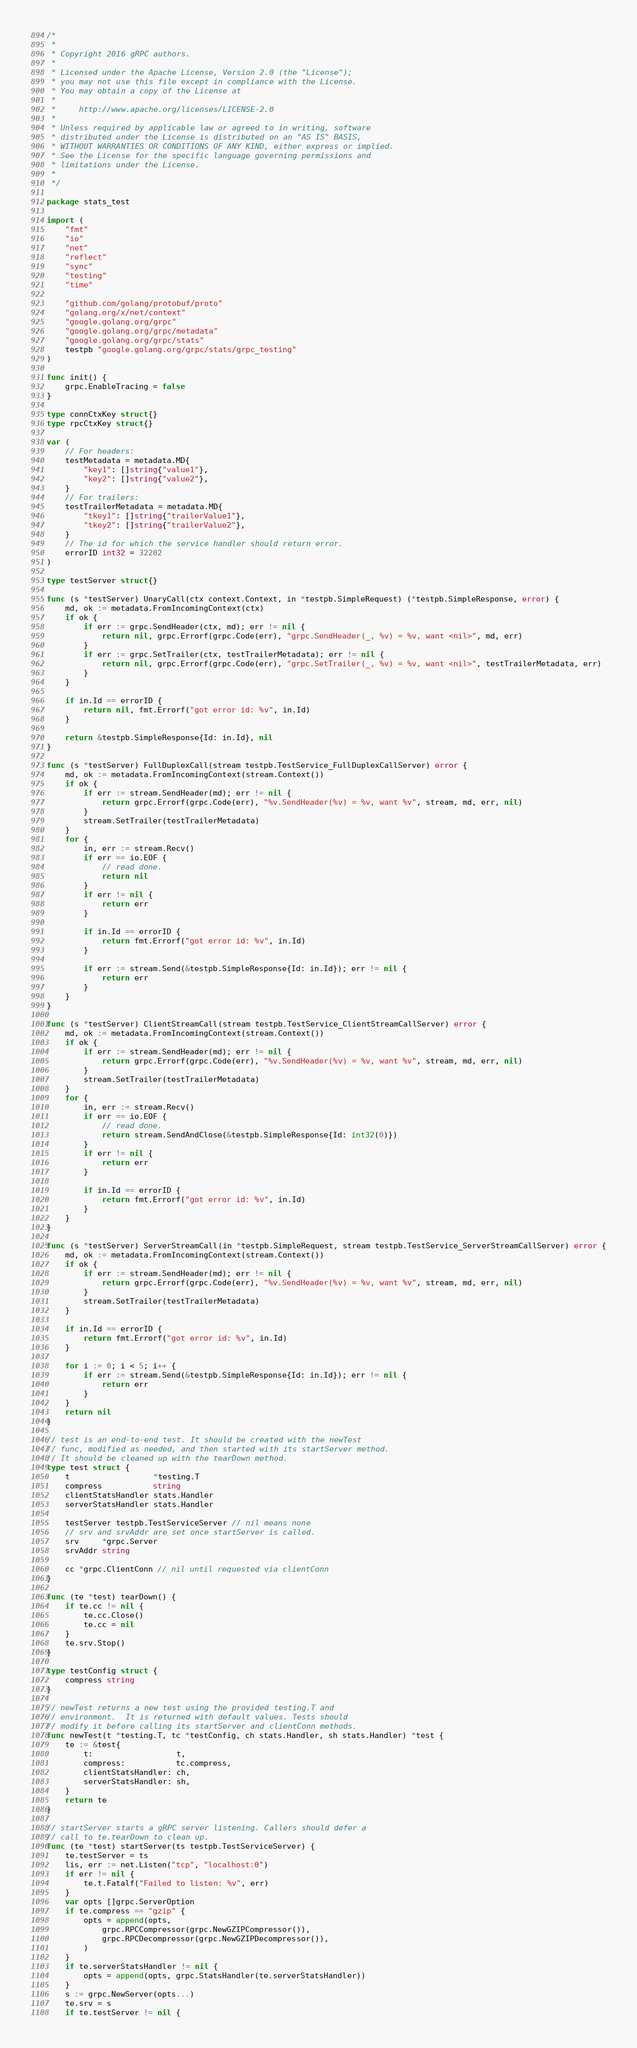Convert code to text. <code><loc_0><loc_0><loc_500><loc_500><_Go_>/*
 *
 * Copyright 2016 gRPC authors.
 *
 * Licensed under the Apache License, Version 2.0 (the "License");
 * you may not use this file except in compliance with the License.
 * You may obtain a copy of the License at
 *
 *     http://www.apache.org/licenses/LICENSE-2.0
 *
 * Unless required by applicable law or agreed to in writing, software
 * distributed under the License is distributed on an "AS IS" BASIS,
 * WITHOUT WARRANTIES OR CONDITIONS OF ANY KIND, either express or implied.
 * See the License for the specific language governing permissions and
 * limitations under the License.
 *
 */

package stats_test

import (
	"fmt"
	"io"
	"net"
	"reflect"
	"sync"
	"testing"
	"time"

	"github.com/golang/protobuf/proto"
	"golang.org/x/net/context"
	"google.golang.org/grpc"
	"google.golang.org/grpc/metadata"
	"google.golang.org/grpc/stats"
	testpb "google.golang.org/grpc/stats/grpc_testing"
)

func init() {
	grpc.EnableTracing = false
}

type connCtxKey struct{}
type rpcCtxKey struct{}

var (
	// For headers:
	testMetadata = metadata.MD{
		"key1": []string{"value1"},
		"key2": []string{"value2"},
	}
	// For trailers:
	testTrailerMetadata = metadata.MD{
		"tkey1": []string{"trailerValue1"},
		"tkey2": []string{"trailerValue2"},
	}
	// The id for which the service handler should return error.
	errorID int32 = 32202
)

type testServer struct{}

func (s *testServer) UnaryCall(ctx context.Context, in *testpb.SimpleRequest) (*testpb.SimpleResponse, error) {
	md, ok := metadata.FromIncomingContext(ctx)
	if ok {
		if err := grpc.SendHeader(ctx, md); err != nil {
			return nil, grpc.Errorf(grpc.Code(err), "grpc.SendHeader(_, %v) = %v, want <nil>", md, err)
		}
		if err := grpc.SetTrailer(ctx, testTrailerMetadata); err != nil {
			return nil, grpc.Errorf(grpc.Code(err), "grpc.SetTrailer(_, %v) = %v, want <nil>", testTrailerMetadata, err)
		}
	}

	if in.Id == errorID {
		return nil, fmt.Errorf("got error id: %v", in.Id)
	}

	return &testpb.SimpleResponse{Id: in.Id}, nil
}

func (s *testServer) FullDuplexCall(stream testpb.TestService_FullDuplexCallServer) error {
	md, ok := metadata.FromIncomingContext(stream.Context())
	if ok {
		if err := stream.SendHeader(md); err != nil {
			return grpc.Errorf(grpc.Code(err), "%v.SendHeader(%v) = %v, want %v", stream, md, err, nil)
		}
		stream.SetTrailer(testTrailerMetadata)
	}
	for {
		in, err := stream.Recv()
		if err == io.EOF {
			// read done.
			return nil
		}
		if err != nil {
			return err
		}

		if in.Id == errorID {
			return fmt.Errorf("got error id: %v", in.Id)
		}

		if err := stream.Send(&testpb.SimpleResponse{Id: in.Id}); err != nil {
			return err
		}
	}
}

func (s *testServer) ClientStreamCall(stream testpb.TestService_ClientStreamCallServer) error {
	md, ok := metadata.FromIncomingContext(stream.Context())
	if ok {
		if err := stream.SendHeader(md); err != nil {
			return grpc.Errorf(grpc.Code(err), "%v.SendHeader(%v) = %v, want %v", stream, md, err, nil)
		}
		stream.SetTrailer(testTrailerMetadata)
	}
	for {
		in, err := stream.Recv()
		if err == io.EOF {
			// read done.
			return stream.SendAndClose(&testpb.SimpleResponse{Id: int32(0)})
		}
		if err != nil {
			return err
		}

		if in.Id == errorID {
			return fmt.Errorf("got error id: %v", in.Id)
		}
	}
}

func (s *testServer) ServerStreamCall(in *testpb.SimpleRequest, stream testpb.TestService_ServerStreamCallServer) error {
	md, ok := metadata.FromIncomingContext(stream.Context())
	if ok {
		if err := stream.SendHeader(md); err != nil {
			return grpc.Errorf(grpc.Code(err), "%v.SendHeader(%v) = %v, want %v", stream, md, err, nil)
		}
		stream.SetTrailer(testTrailerMetadata)
	}

	if in.Id == errorID {
		return fmt.Errorf("got error id: %v", in.Id)
	}

	for i := 0; i < 5; i++ {
		if err := stream.Send(&testpb.SimpleResponse{Id: in.Id}); err != nil {
			return err
		}
	}
	return nil
}

// test is an end-to-end test. It should be created with the newTest
// func, modified as needed, and then started with its startServer method.
// It should be cleaned up with the tearDown method.
type test struct {
	t                  *testing.T
	compress           string
	clientStatsHandler stats.Handler
	serverStatsHandler stats.Handler

	testServer testpb.TestServiceServer // nil means none
	// srv and srvAddr are set once startServer is called.
	srv     *grpc.Server
	srvAddr string

	cc *grpc.ClientConn // nil until requested via clientConn
}

func (te *test) tearDown() {
	if te.cc != nil {
		te.cc.Close()
		te.cc = nil
	}
	te.srv.Stop()
}

type testConfig struct {
	compress string
}

// newTest returns a new test using the provided testing.T and
// environment.  It is returned with default values. Tests should
// modify it before calling its startServer and clientConn methods.
func newTest(t *testing.T, tc *testConfig, ch stats.Handler, sh stats.Handler) *test {
	te := &test{
		t:                  t,
		compress:           tc.compress,
		clientStatsHandler: ch,
		serverStatsHandler: sh,
	}
	return te
}

// startServer starts a gRPC server listening. Callers should defer a
// call to te.tearDown to clean up.
func (te *test) startServer(ts testpb.TestServiceServer) {
	te.testServer = ts
	lis, err := net.Listen("tcp", "localhost:0")
	if err != nil {
		te.t.Fatalf("Failed to listen: %v", err)
	}
	var opts []grpc.ServerOption
	if te.compress == "gzip" {
		opts = append(opts,
			grpc.RPCCompressor(grpc.NewGZIPCompressor()),
			grpc.RPCDecompressor(grpc.NewGZIPDecompressor()),
		)
	}
	if te.serverStatsHandler != nil {
		opts = append(opts, grpc.StatsHandler(te.serverStatsHandler))
	}
	s := grpc.NewServer(opts...)
	te.srv = s
	if te.testServer != nil {</code> 